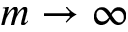<formula> <loc_0><loc_0><loc_500><loc_500>m \rightarrow \infty</formula> 